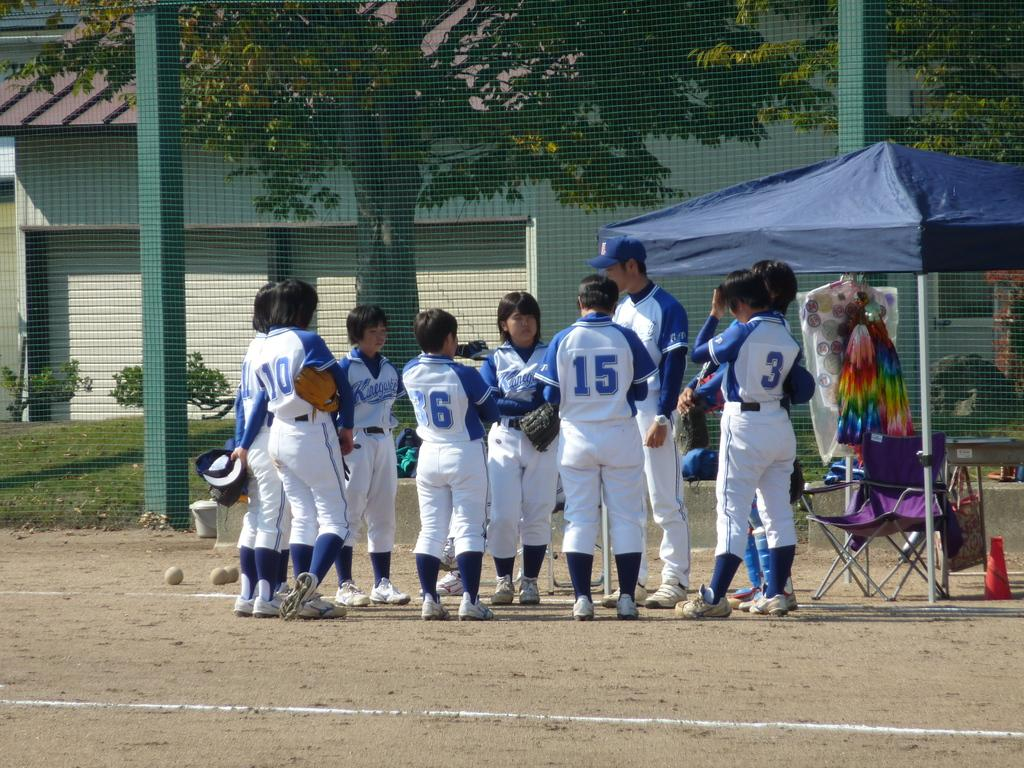<image>
Describe the image concisely. A group of people wearing blue and white Kinegars jerseys. 